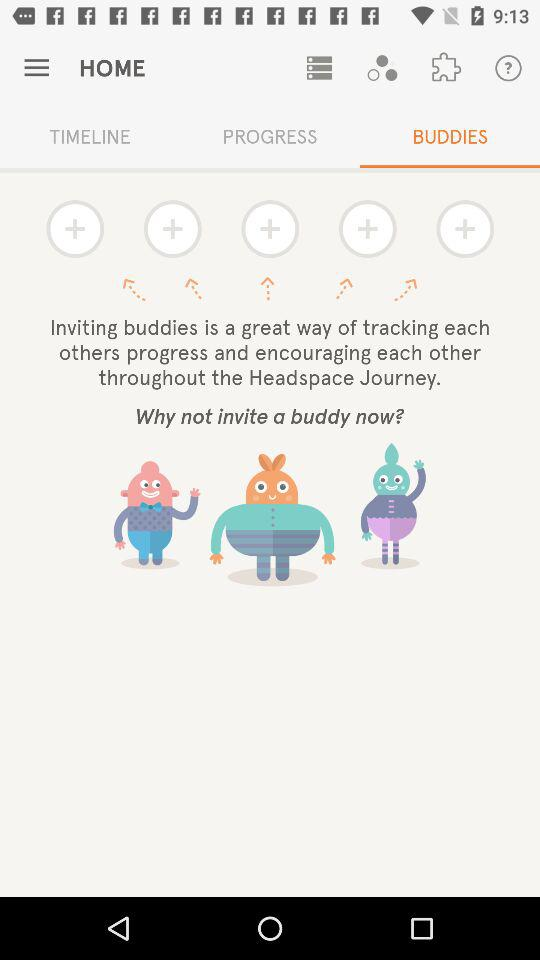How many buddies can we add?
When the provided information is insufficient, respond with <no answer>. <no answer> 